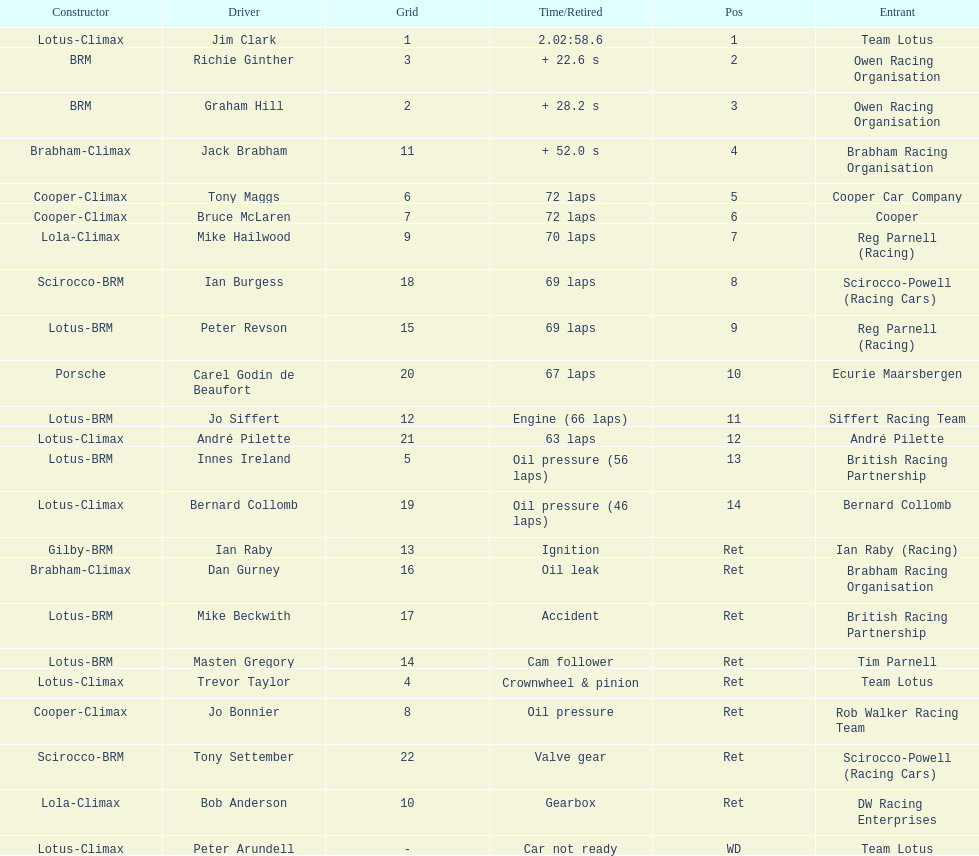What is the number of americans in the top 5? 1. 